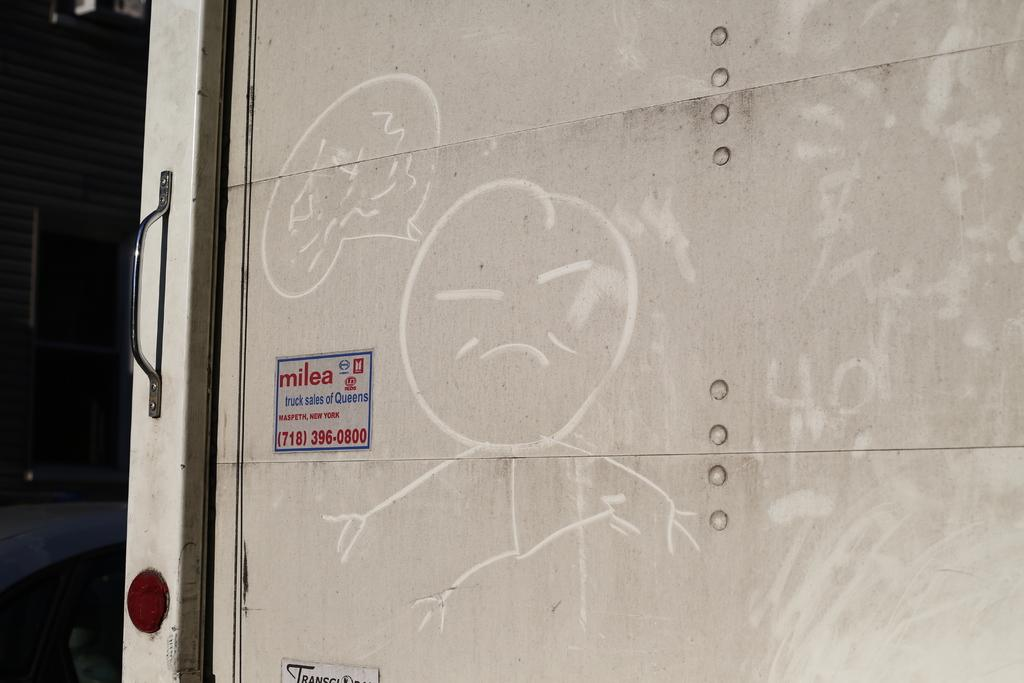What is present on the wall in the image? There are posters and drawings on the wall in the image. Can you describe the door handle in the image? Yes, there is a door handle visible in the image. What can be seen in the background of the image? There are objects visible in the background of the image. What type of eggs can be seen floating on the waves in the image? There are no eggs or waves present in the image; it features posters, drawings, and a door handle. 